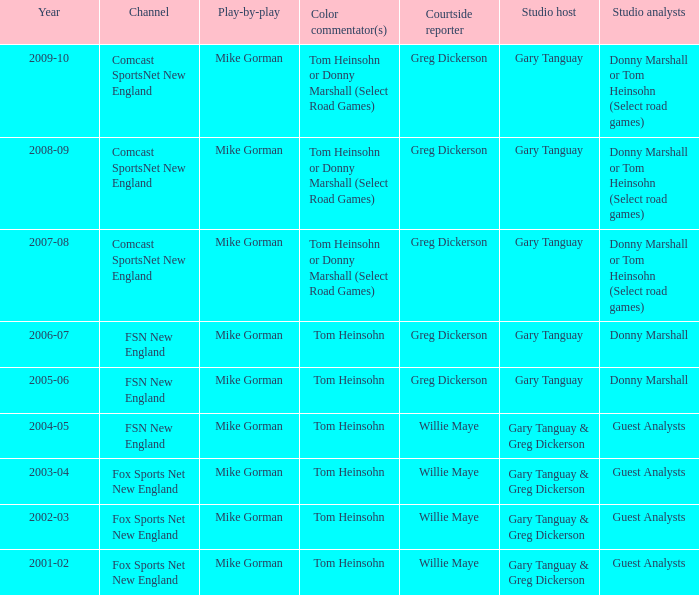How many channels were the games shown on in 2001-02? 1.0. Give me the full table as a dictionary. {'header': ['Year', 'Channel', 'Play-by-play', 'Color commentator(s)', 'Courtside reporter', 'Studio host', 'Studio analysts'], 'rows': [['2009-10', 'Comcast SportsNet New England', 'Mike Gorman', 'Tom Heinsohn or Donny Marshall (Select Road Games)', 'Greg Dickerson', 'Gary Tanguay', 'Donny Marshall or Tom Heinsohn (Select road games)'], ['2008-09', 'Comcast SportsNet New England', 'Mike Gorman', 'Tom Heinsohn or Donny Marshall (Select Road Games)', 'Greg Dickerson', 'Gary Tanguay', 'Donny Marshall or Tom Heinsohn (Select road games)'], ['2007-08', 'Comcast SportsNet New England', 'Mike Gorman', 'Tom Heinsohn or Donny Marshall (Select Road Games)', 'Greg Dickerson', 'Gary Tanguay', 'Donny Marshall or Tom Heinsohn (Select road games)'], ['2006-07', 'FSN New England', 'Mike Gorman', 'Tom Heinsohn', 'Greg Dickerson', 'Gary Tanguay', 'Donny Marshall'], ['2005-06', 'FSN New England', 'Mike Gorman', 'Tom Heinsohn', 'Greg Dickerson', 'Gary Tanguay', 'Donny Marshall'], ['2004-05', 'FSN New England', 'Mike Gorman', 'Tom Heinsohn', 'Willie Maye', 'Gary Tanguay & Greg Dickerson', 'Guest Analysts'], ['2003-04', 'Fox Sports Net New England', 'Mike Gorman', 'Tom Heinsohn', 'Willie Maye', 'Gary Tanguay & Greg Dickerson', 'Guest Analysts'], ['2002-03', 'Fox Sports Net New England', 'Mike Gorman', 'Tom Heinsohn', 'Willie Maye', 'Gary Tanguay & Greg Dickerson', 'Guest Analysts'], ['2001-02', 'Fox Sports Net New England', 'Mike Gorman', 'Tom Heinsohn', 'Willie Maye', 'Gary Tanguay & Greg Dickerson', 'Guest Analysts']]} 